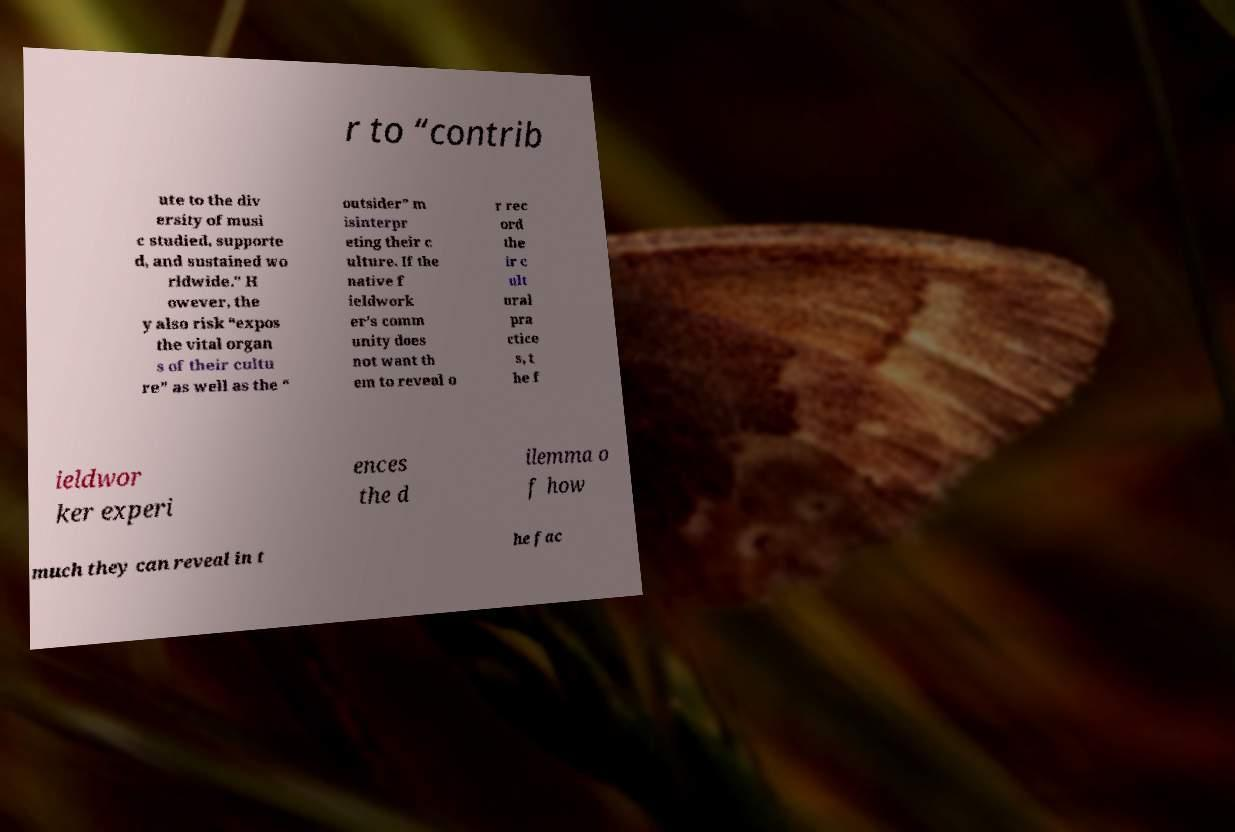I need the written content from this picture converted into text. Can you do that? r to “contrib ute to the div ersity of musi c studied, supporte d, and sustained wo rldwide." H owever, the y also risk “expos the vital organ s of their cultu re” as well as the “ outsider” m isinterpr eting their c ulture. If the native f ieldwork er’s comm unity does not want th em to reveal o r rec ord the ir c ult ural pra ctice s, t he f ieldwor ker experi ences the d ilemma o f how much they can reveal in t he fac 